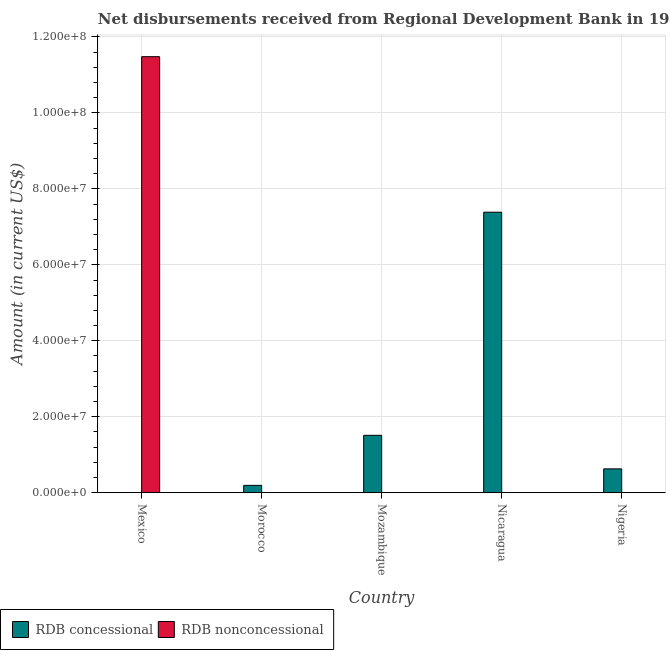How many different coloured bars are there?
Give a very brief answer. 2. Are the number of bars per tick equal to the number of legend labels?
Your answer should be compact. No. How many bars are there on the 5th tick from the left?
Provide a succinct answer. 1. What is the label of the 3rd group of bars from the left?
Provide a succinct answer. Mozambique. What is the net concessional disbursements from rdb in Morocco?
Ensure brevity in your answer.  1.93e+06. Across all countries, what is the maximum net concessional disbursements from rdb?
Your response must be concise. 7.39e+07. In which country was the net non concessional disbursements from rdb maximum?
Offer a terse response. Mexico. What is the total net concessional disbursements from rdb in the graph?
Make the answer very short. 9.72e+07. What is the difference between the net concessional disbursements from rdb in Mozambique and that in Nicaragua?
Provide a short and direct response. -5.88e+07. What is the difference between the net non concessional disbursements from rdb in Morocco and the net concessional disbursements from rdb in Nicaragua?
Your answer should be compact. -7.39e+07. What is the average net concessional disbursements from rdb per country?
Your answer should be very brief. 1.94e+07. In how many countries, is the net non concessional disbursements from rdb greater than 96000000 US$?
Make the answer very short. 1. What is the ratio of the net concessional disbursements from rdb in Mozambique to that in Nicaragua?
Keep it short and to the point. 0.2. What is the difference between the highest and the second highest net concessional disbursements from rdb?
Your response must be concise. 5.88e+07. What is the difference between the highest and the lowest net non concessional disbursements from rdb?
Your answer should be compact. 1.15e+08. Are all the bars in the graph horizontal?
Your answer should be very brief. No. Are the values on the major ticks of Y-axis written in scientific E-notation?
Ensure brevity in your answer.  Yes. Does the graph contain grids?
Make the answer very short. Yes. How many legend labels are there?
Your answer should be compact. 2. How are the legend labels stacked?
Provide a short and direct response. Horizontal. What is the title of the graph?
Provide a succinct answer. Net disbursements received from Regional Development Bank in 1999. What is the Amount (in current US$) in RDB concessional in Mexico?
Provide a short and direct response. 0. What is the Amount (in current US$) in RDB nonconcessional in Mexico?
Your answer should be compact. 1.15e+08. What is the Amount (in current US$) of RDB concessional in Morocco?
Make the answer very short. 1.93e+06. What is the Amount (in current US$) of RDB concessional in Mozambique?
Provide a succinct answer. 1.51e+07. What is the Amount (in current US$) of RDB concessional in Nicaragua?
Offer a very short reply. 7.39e+07. What is the Amount (in current US$) of RDB nonconcessional in Nicaragua?
Ensure brevity in your answer.  0. What is the Amount (in current US$) in RDB concessional in Nigeria?
Provide a short and direct response. 6.28e+06. Across all countries, what is the maximum Amount (in current US$) in RDB concessional?
Ensure brevity in your answer.  7.39e+07. Across all countries, what is the maximum Amount (in current US$) of RDB nonconcessional?
Offer a very short reply. 1.15e+08. What is the total Amount (in current US$) of RDB concessional in the graph?
Give a very brief answer. 9.72e+07. What is the total Amount (in current US$) in RDB nonconcessional in the graph?
Keep it short and to the point. 1.15e+08. What is the difference between the Amount (in current US$) of RDB concessional in Morocco and that in Mozambique?
Ensure brevity in your answer.  -1.32e+07. What is the difference between the Amount (in current US$) of RDB concessional in Morocco and that in Nicaragua?
Your answer should be compact. -7.19e+07. What is the difference between the Amount (in current US$) of RDB concessional in Morocco and that in Nigeria?
Offer a very short reply. -4.34e+06. What is the difference between the Amount (in current US$) of RDB concessional in Mozambique and that in Nicaragua?
Give a very brief answer. -5.88e+07. What is the difference between the Amount (in current US$) of RDB concessional in Mozambique and that in Nigeria?
Provide a succinct answer. 8.83e+06. What is the difference between the Amount (in current US$) of RDB concessional in Nicaragua and that in Nigeria?
Your response must be concise. 6.76e+07. What is the average Amount (in current US$) of RDB concessional per country?
Provide a succinct answer. 1.94e+07. What is the average Amount (in current US$) of RDB nonconcessional per country?
Give a very brief answer. 2.30e+07. What is the ratio of the Amount (in current US$) in RDB concessional in Morocco to that in Mozambique?
Offer a terse response. 0.13. What is the ratio of the Amount (in current US$) in RDB concessional in Morocco to that in Nicaragua?
Offer a terse response. 0.03. What is the ratio of the Amount (in current US$) in RDB concessional in Morocco to that in Nigeria?
Provide a short and direct response. 0.31. What is the ratio of the Amount (in current US$) of RDB concessional in Mozambique to that in Nicaragua?
Provide a short and direct response. 0.2. What is the ratio of the Amount (in current US$) of RDB concessional in Mozambique to that in Nigeria?
Your answer should be compact. 2.41. What is the ratio of the Amount (in current US$) in RDB concessional in Nicaragua to that in Nigeria?
Ensure brevity in your answer.  11.77. What is the difference between the highest and the second highest Amount (in current US$) of RDB concessional?
Offer a terse response. 5.88e+07. What is the difference between the highest and the lowest Amount (in current US$) of RDB concessional?
Provide a short and direct response. 7.39e+07. What is the difference between the highest and the lowest Amount (in current US$) in RDB nonconcessional?
Ensure brevity in your answer.  1.15e+08. 